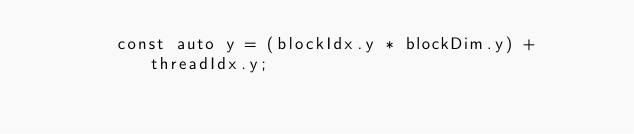<code> <loc_0><loc_0><loc_500><loc_500><_Cuda_>        const auto y = (blockIdx.y * blockDim.y) + threadIdx.y;</code> 